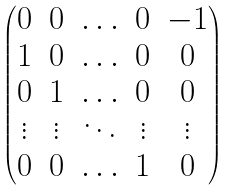<formula> <loc_0><loc_0><loc_500><loc_500>\begin{pmatrix} 0 & 0 & \hdots & 0 & - 1 \\ 1 & 0 & \hdots & 0 & 0 \\ 0 & 1 & \hdots & 0 & 0 \\ \vdots & \vdots & \ddots & \vdots & \vdots \\ 0 & 0 & \hdots & 1 & 0 \end{pmatrix}</formula> 